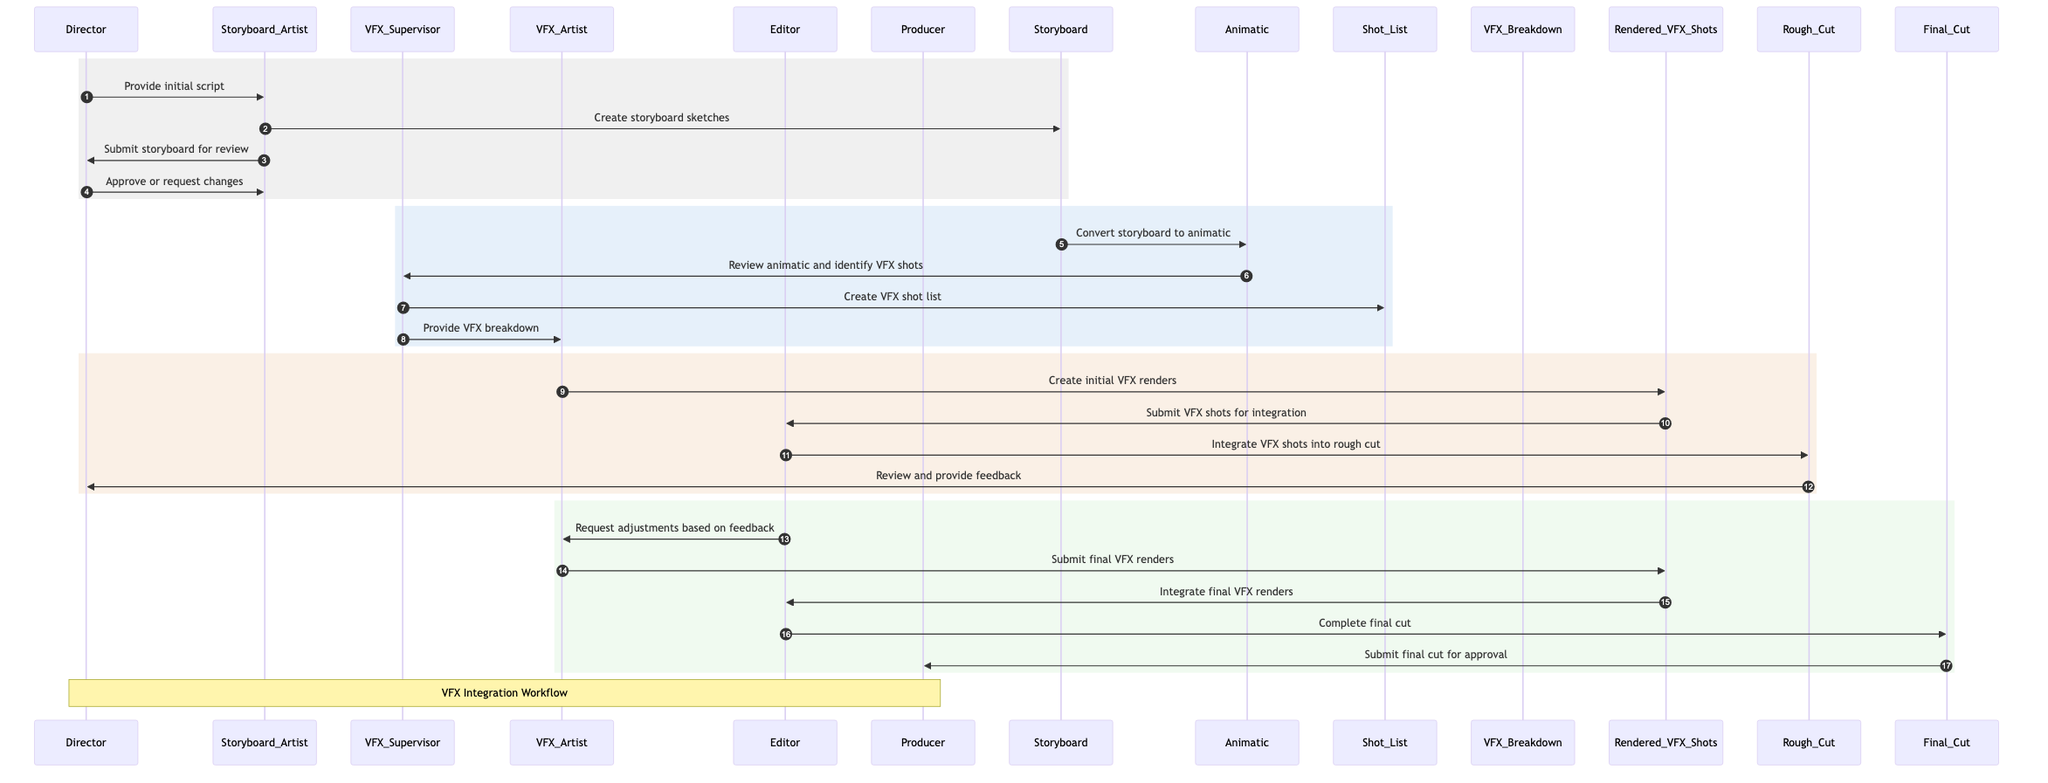What is the first action taken in the workflow? The first action is the Director providing the initial script to the Storyboard Artist. This is indicated by the first message in the flow of the sequence diagram.
Answer: Provide initial script How many actors are involved in the diagram? The diagram includes six actors: Director, Storyboard Artist, VFX Supervisor, VFX Artist, Editor, and Producer. Counting each distinct participating actor gives the total.
Answer: Six What is created after the storyboard sketches are submitted for review? After the storyboard sketches are submitted to the Director for review, the next action is for the Director to approve or request changes. This follows immediately in the sequence.
Answer: Approve or request changes Who receives the VFX breakdown from the VFX Supervisor? The VFX breakdown is provided to the VFX Artist by the VFX Supervisor. This direct interaction identifies who receives what in the workflow.
Answer: VFX Artist What happens after the Rough Cut is reviewed by the Director? After the Rough Cut is reviewed by the Director, the Editor requests adjustments based on the feedback. This connection illustrates the iterative nature of the workflow.
Answer: Request adjustments based on feedback How many messages flow between the Editor and Rendered VFX Shots? There are three distinct messages flowing between the Editor and Rendered VFX Shots in the sequence: the submission of VFX shots for integration, the integration of final VFX renders, and the submission of the final cut for approval, noting the connections in the sequence.
Answer: Three What type of document is submitted for approval at the end of the workflow? The document submitted for approval at the end of the workflow is the final cut of the film project. This is specifically indicated as the final message in the sequence.
Answer: Final Cut What does the VFX Artist create from the Rendered VFX Shots? The VFX Artist creates initial VFX renders from the Rendered VFX Shots, as highlighted in the flow between these two participants in the sequence.
Answer: Create initial VFX renders Which phase comes after the submission of the VFX shots for integration? The phase that follows the submission of VFX shots for integration by the Editor is the integration of VFX shots into the Rough Cut, demonstrating the progression in the sequence.
Answer: Integrate VFX shots into rough cut 